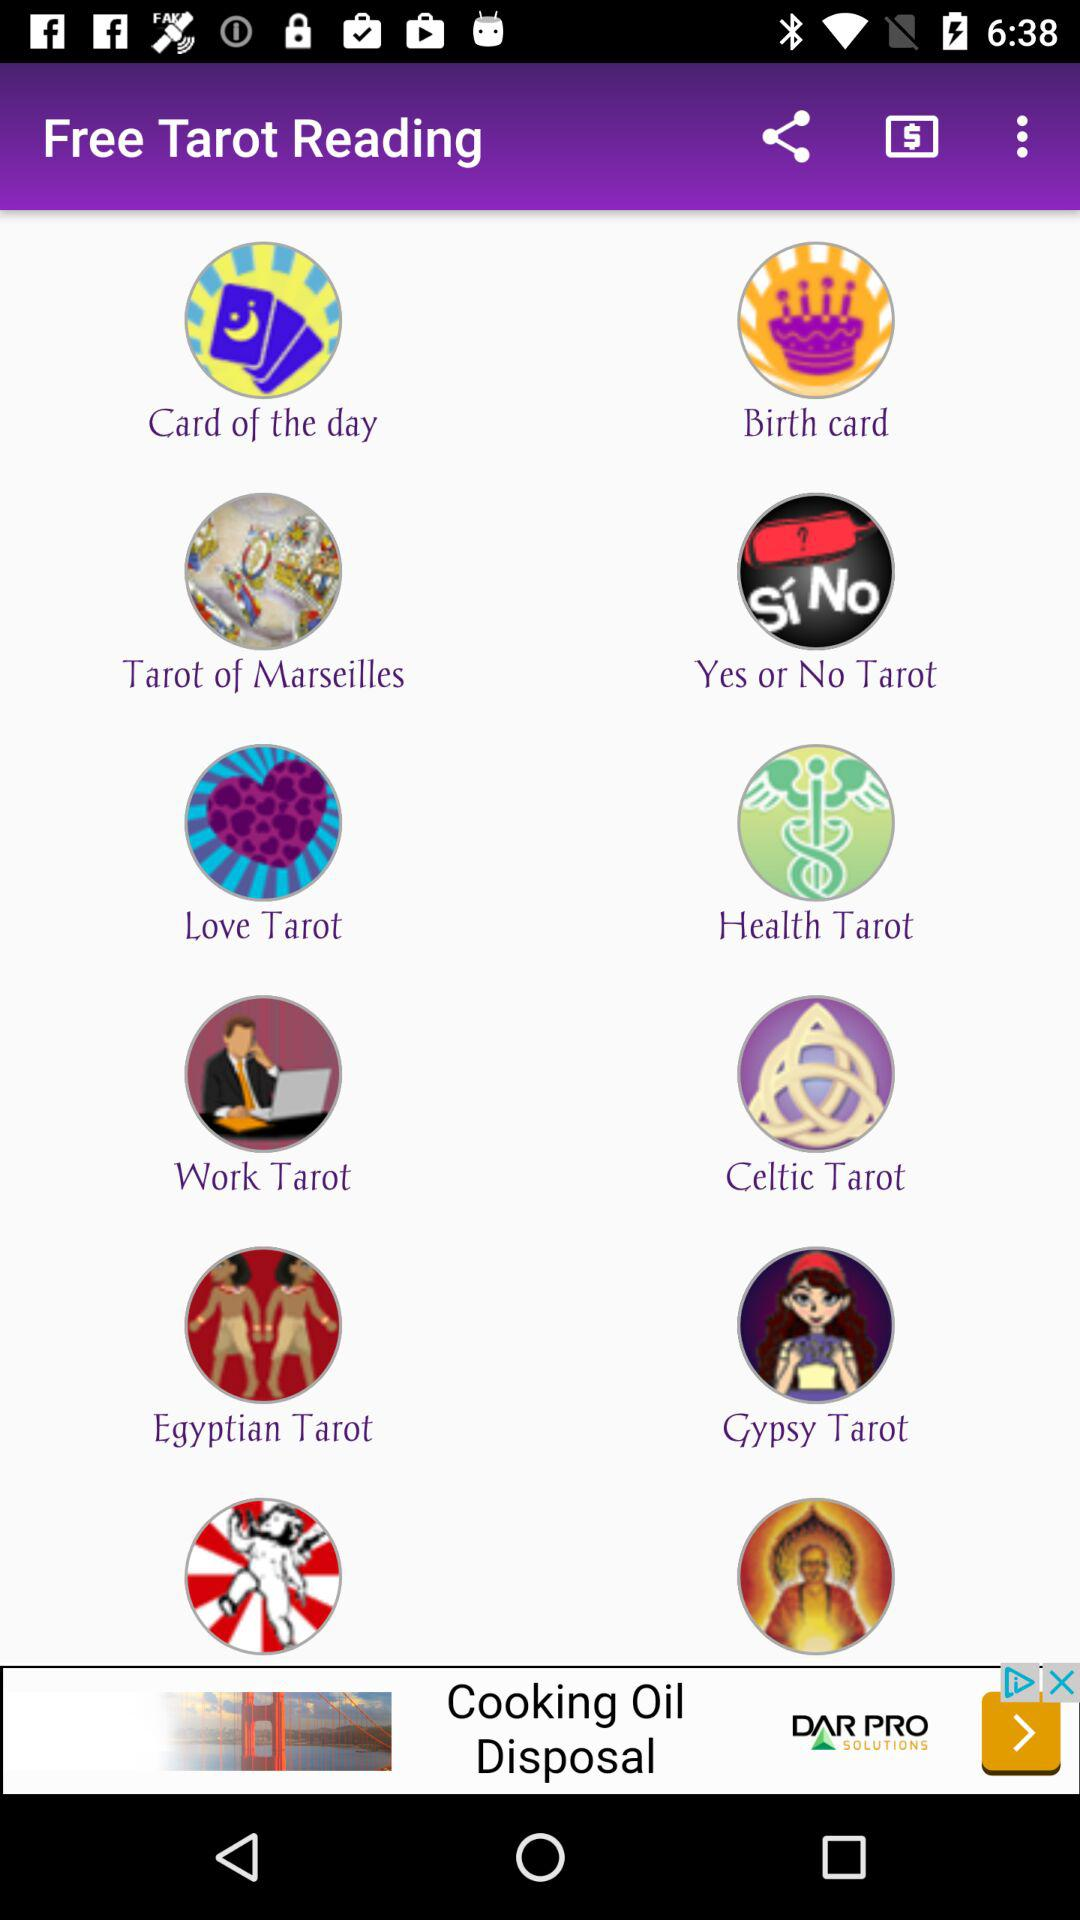What is the application name? The application name is "Free Tarot Reading". 